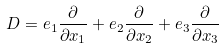<formula> <loc_0><loc_0><loc_500><loc_500>D = e _ { 1 } \frac { \partial } { \partial { x _ { 1 } } } + e _ { 2 } \frac { \partial } { \partial { x _ { 2 } } } + e _ { 3 } \frac { \partial } { \partial { x _ { 3 } } }</formula> 